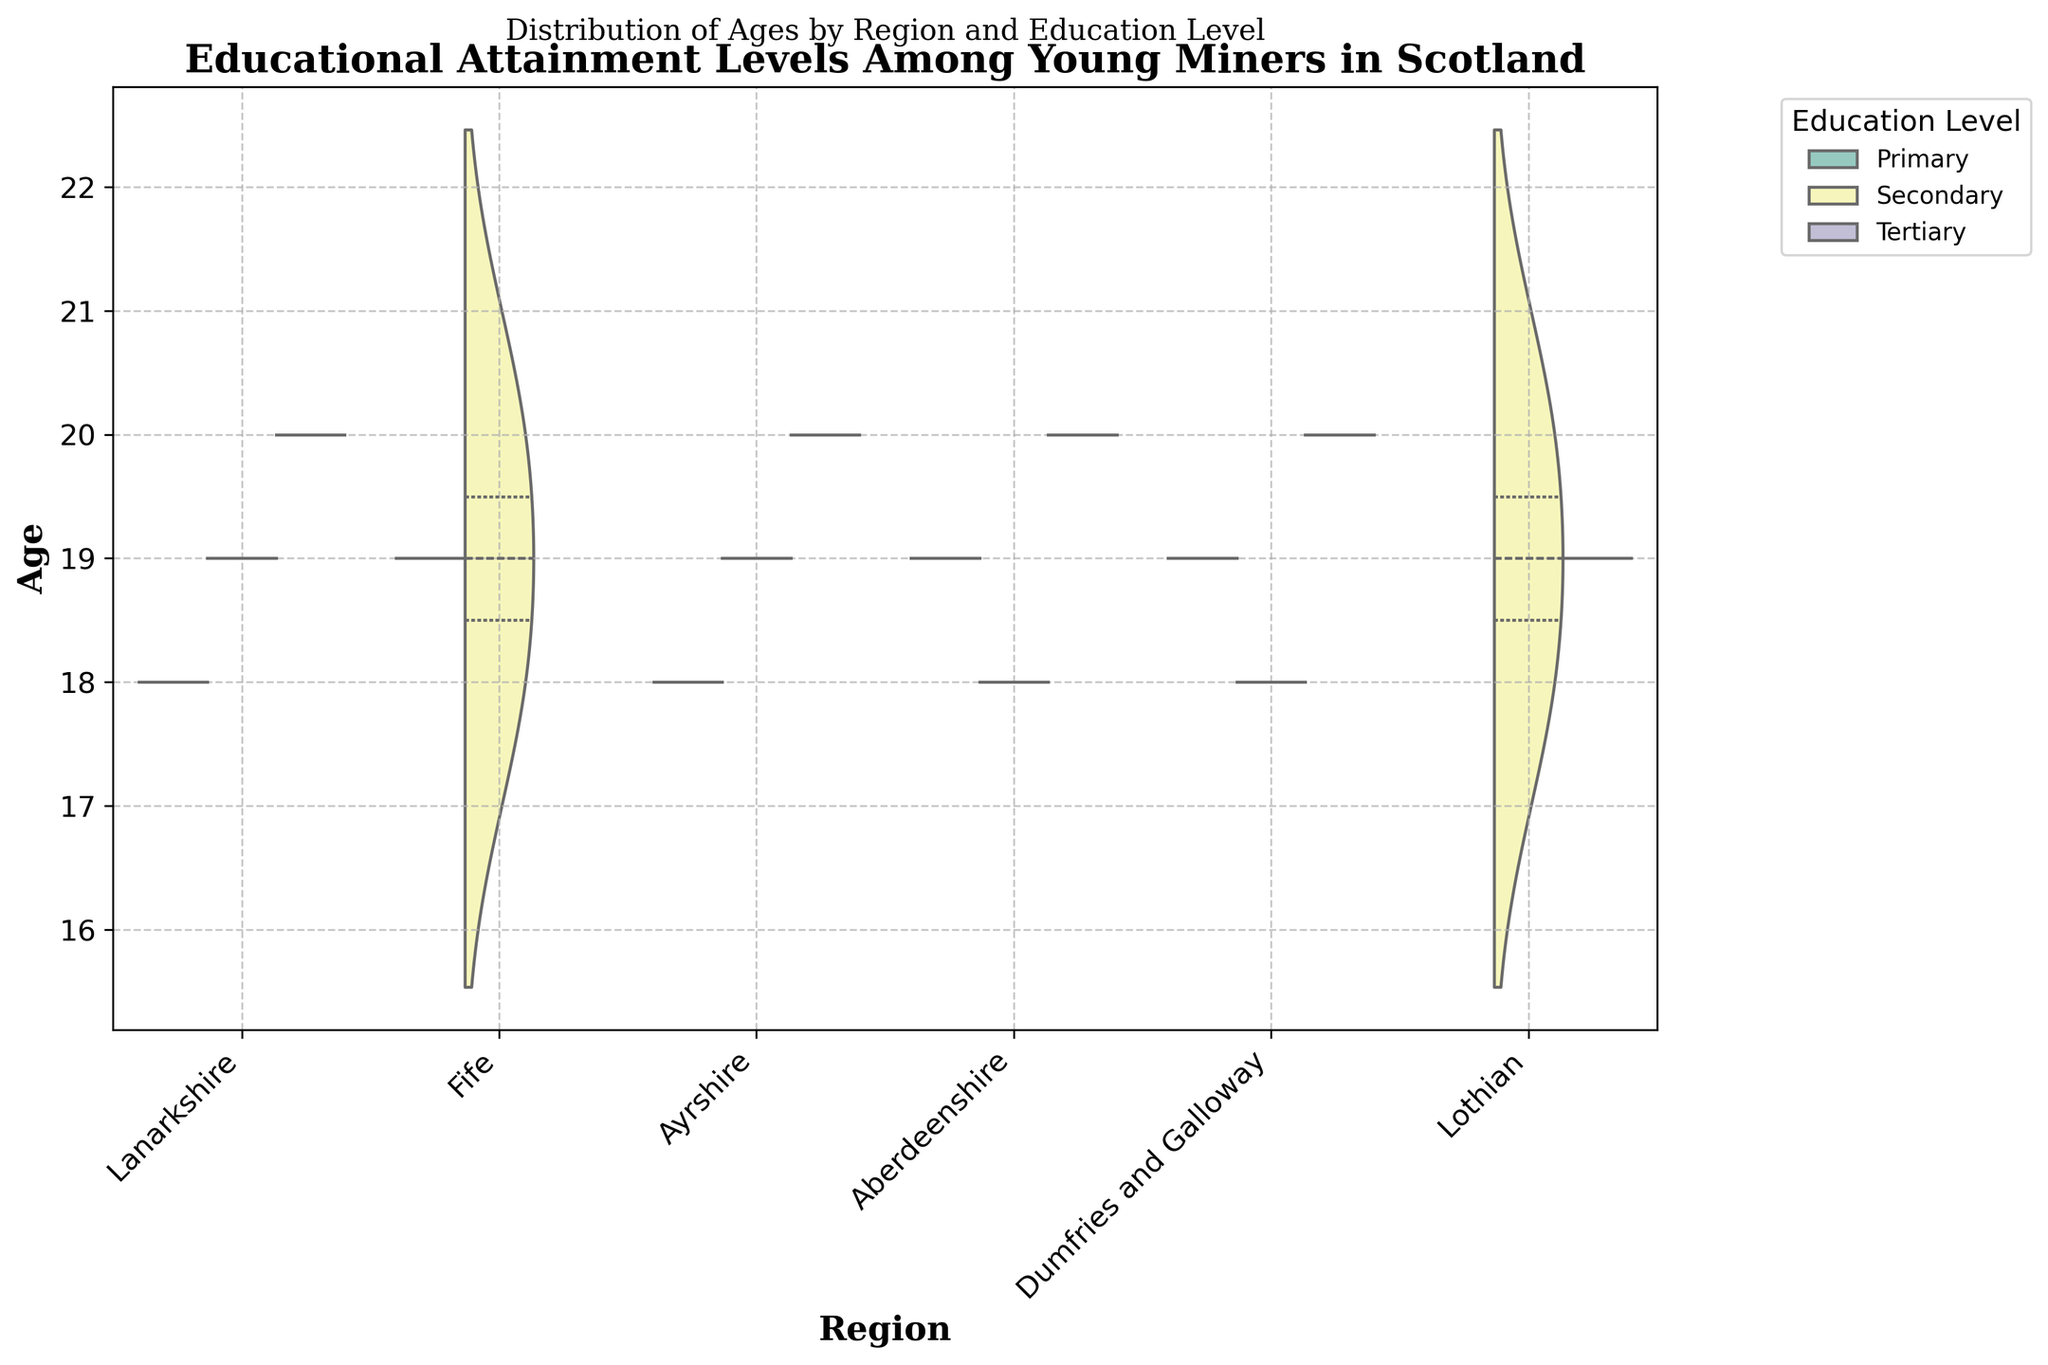What's the title of the plot? The title is prominently displayed at the top of the chart and reads "Educational Attainment Levels Among Young Miners in Scotland".
Answer: Educational Attainment Levels Among Young Miners in Scotland What's the age range of the miners illustrated in the violin plot? Looking at the y-axis, we can see that the ages of the miners range from 18 to 20.
Answer: 18 to 20 Which region shows the widest distribution of ages across educational levels? By observing the width and spread of the violins, it appears that regions like Lanarkshire and Ayrshire show a wider distribution of ages compared to others.
Answer: Lanarkshire and Ayrshire How does the age distribution of miners with secondary education compare between Fife and Lothian? In Fife, miners with secondary education are both 18 and 20 years old whereas, in Lothian, they are mainly concentrated around the ages of 18 and 20. This suggests a similar distribution in terms of age span.
Answer: Similar distribution Which region has miners with tertiary education at the youngest age? By looking at the violins for tertiary education, we can see that the youngest age appears in Lanarkshire, where miners as young as 20 have attained tertiary education.
Answer: Lanarkshire Are there any regions without miners in the primary education category? Observing the hue for primary education, all regions presented in the plot including Lanarkshire, Ayrshire, Fife, Aberdeenshire, Dumfries and Galloway, and Lothian show some level of distribution, indicating that no region is without miners in the primary education category.
Answer: None What can we infer about the educational attainment of miners aged 19 in Dumfries and Galloway? Examining the distribution, miners aged 19 in Dumfries and Galloway predominantly fall within the primary education level, as indicated by the 'split' in the violin.
Answer: Primary education Which region has the narrowest age range for miners with tertiary education? By looking at the violin shapes for tertiary education, Fife shows the narrowest distribution of ages for miners with tertiary education (concentrated around age 20).
Answer: Fife In which regions do miners aged 18 predominately have secondary education? In regions like Fife, Aberdeenshire, Dumfries and Galloway, and Lothian, miners aged 18 predominantly have secondary education as seen by the majority of the violin's data for that age group.
Answer: Fife, Aberdeenshire, Dumfries and Galloway, Lothian 